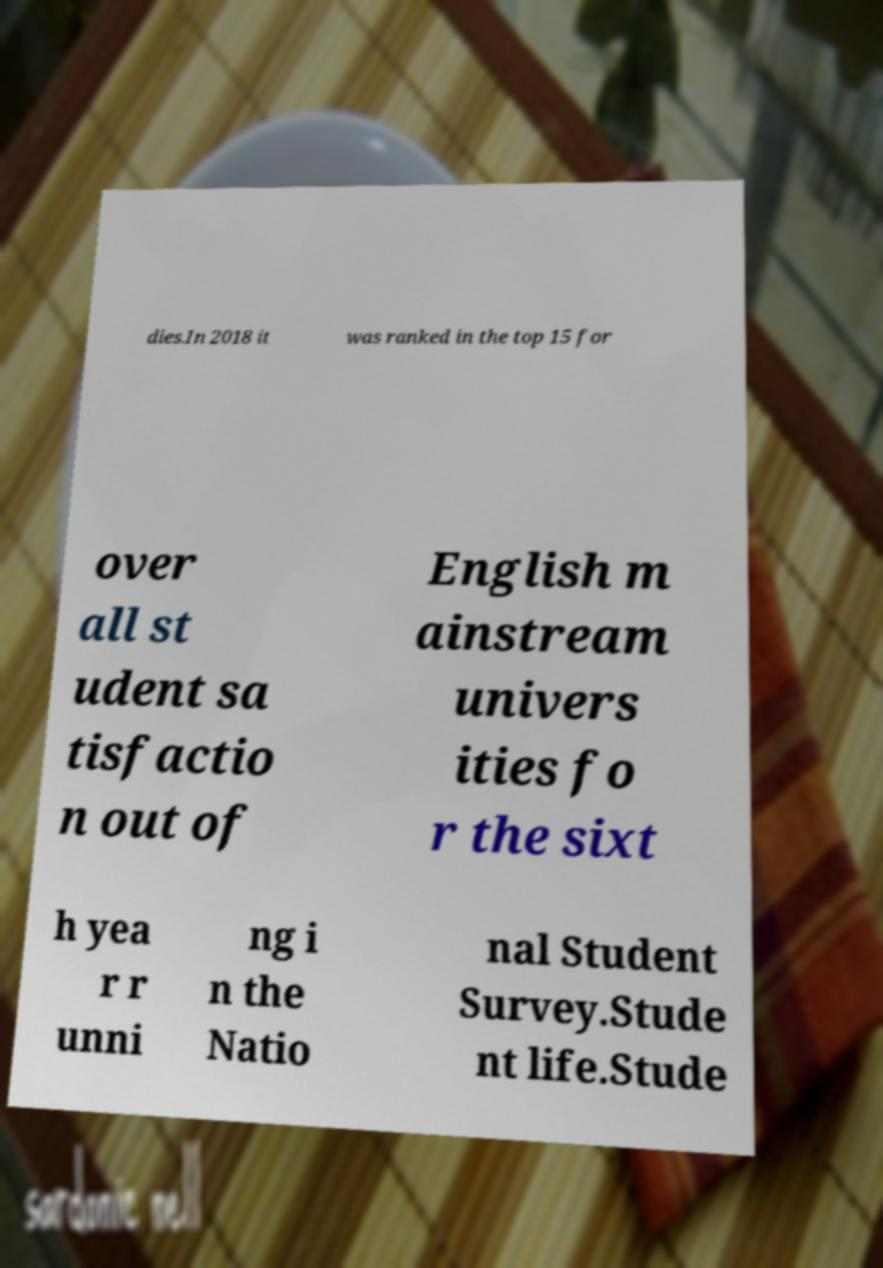Can you accurately transcribe the text from the provided image for me? dies.In 2018 it was ranked in the top 15 for over all st udent sa tisfactio n out of English m ainstream univers ities fo r the sixt h yea r r unni ng i n the Natio nal Student Survey.Stude nt life.Stude 